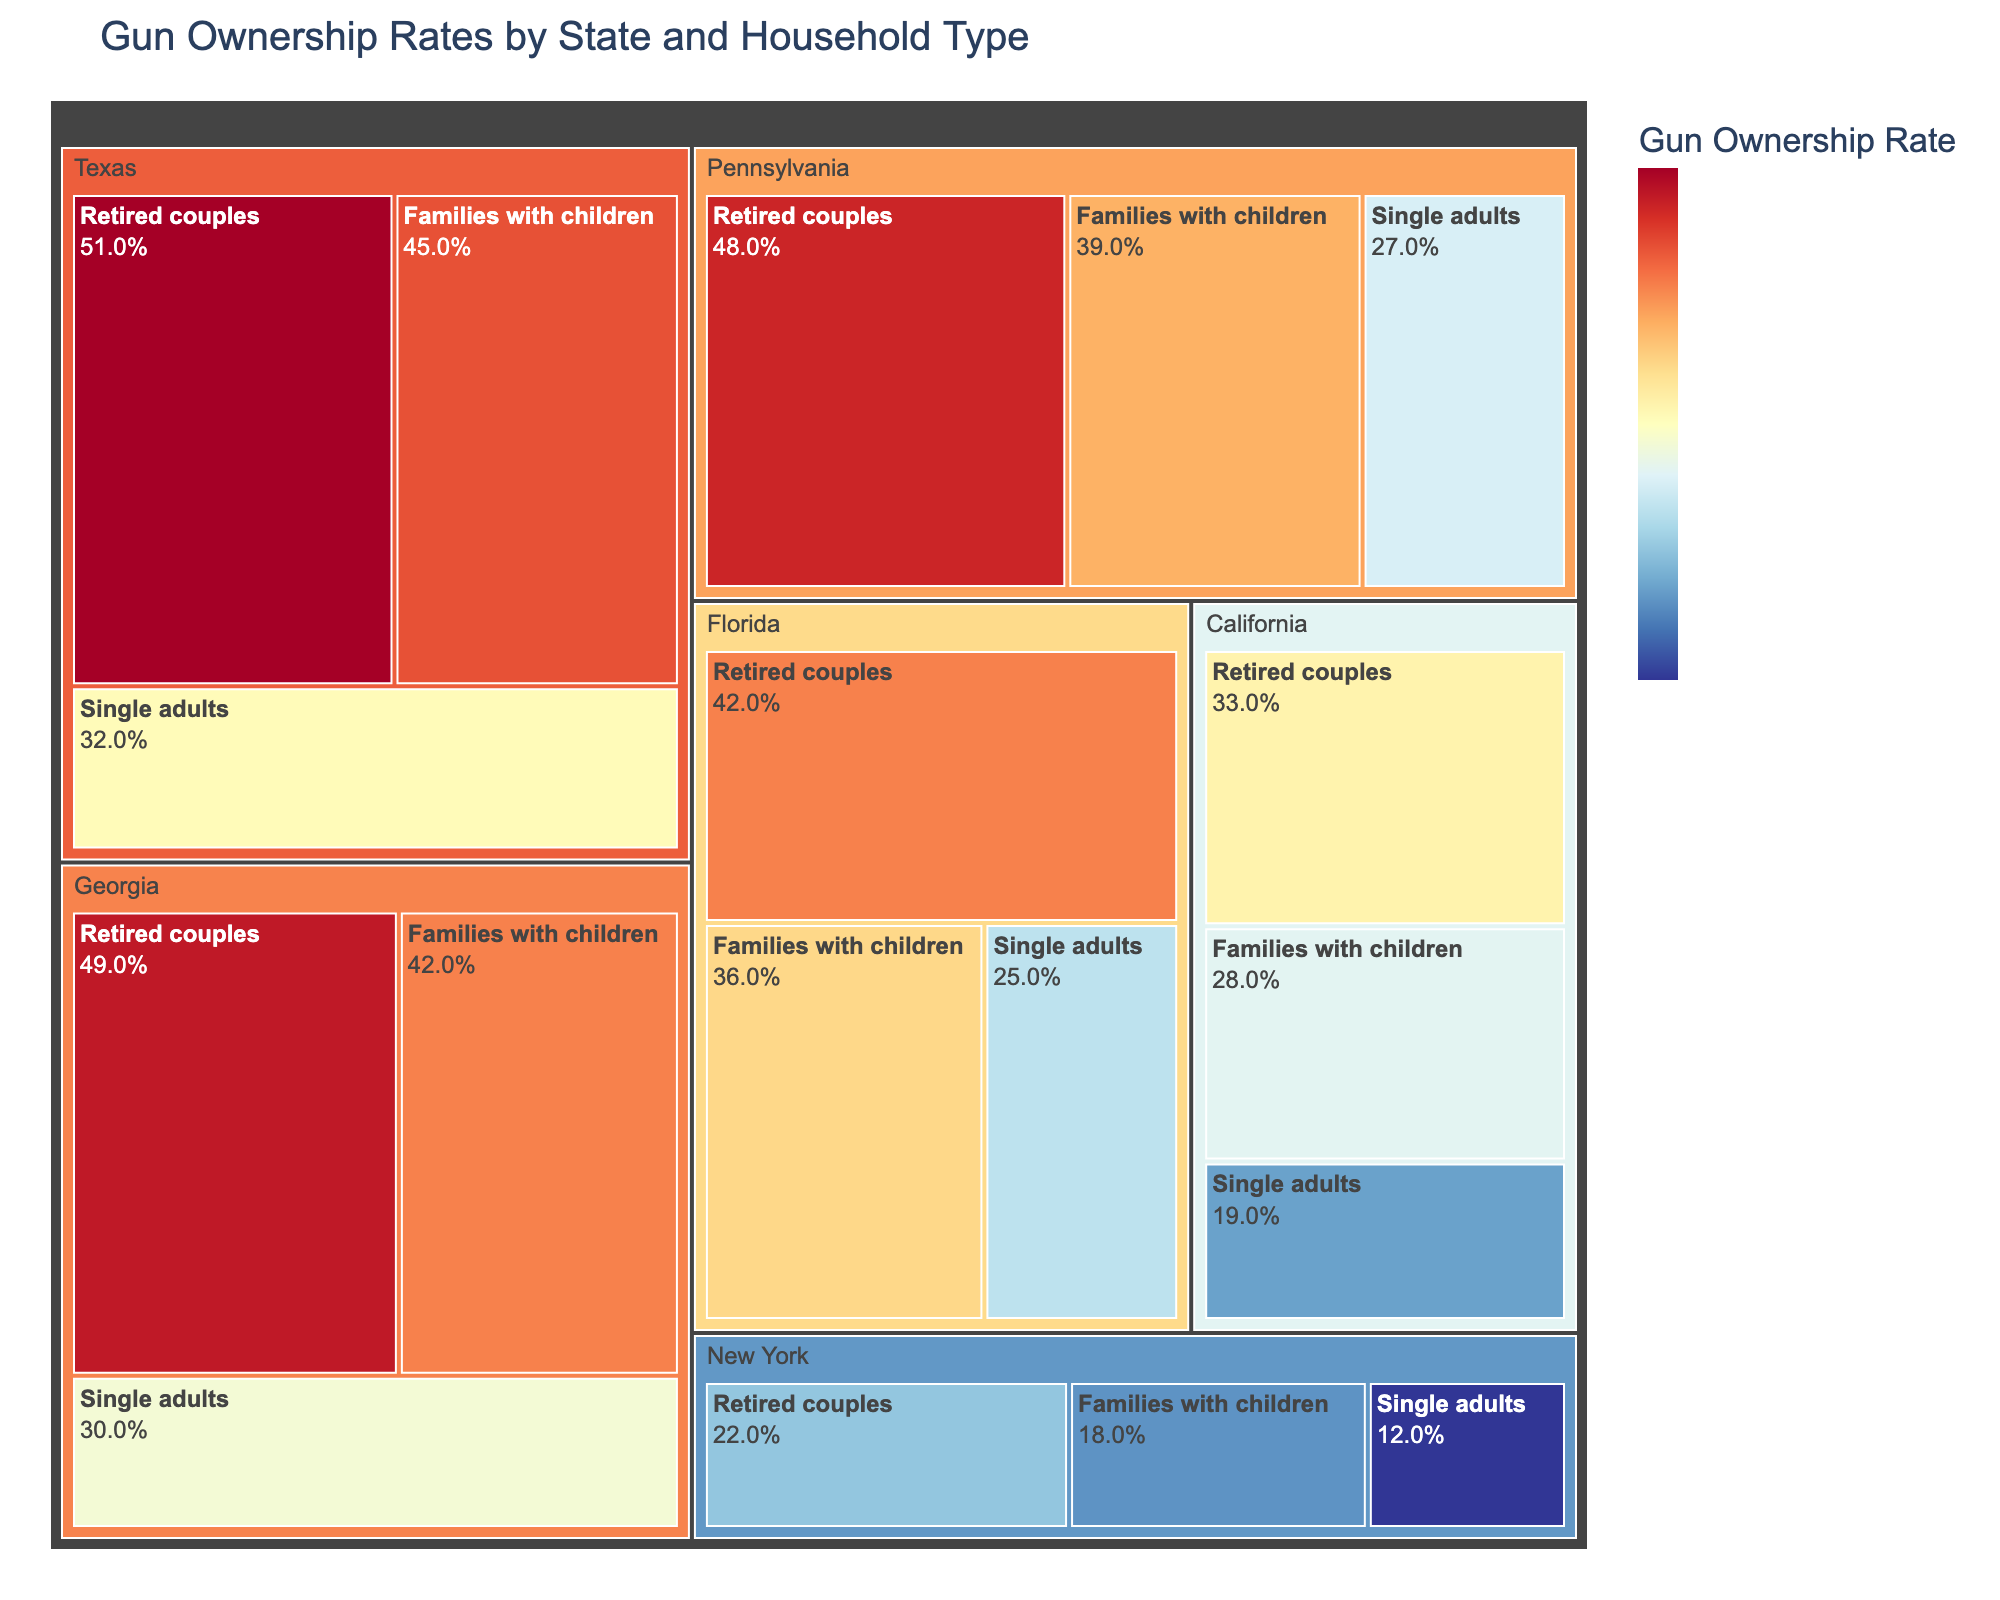What state has the highest gun ownership rate among retired couples? Identify the state with the highest value for "Retired couples" by visually analyzing the respective sections of the Treemap.
Answer: Texas Which household type in New York has the lowest gun ownership rate? Locate New York on the Treemap, then determine which household type ("Families with children," "Single adults," or "Retired couples") has the smallest associated value.
Answer: Single adults What is the average gun ownership rate for all household types in Pennsylvania? Find and sum the gun ownership rates for "Families with children" (0.39), "Single adults" (0.27), and "Retired couples" (0.48). Then, divide by the number of household types (3).
Answer: 0.38 Compare the gun ownership rates of retired couples in California and Florida. Which state has a higher rate? Identify the rates for "Retired couples" in California and Florida, then compare these values.
Answer: Florida What is the difference in gun ownership rate between families with children in Texas and single adults in Georgia? Find the ownership rates for "Families with children" in Texas (0.45) and "Single adults" in Georgia (0.30) and calculate the difference (0.45 - 0.30).
Answer: 0.15 Which state has the lowest overall gun ownership rate for "Single adults"? Compare the "Single adults" ownership rates across all states and identify the smallest value.
Answer: New York Is the gun ownership rate among families with children in Georgia higher or lower than in Pennsylvania? Compare the "Families with children" ownership rates in Georgia (0.42) and Pennsylvania (0.39).
Answer: Higher What is the total gun ownership rate for all household types in Florida? Sum the ownership rates for "Families with children" (0.36), "Single adults" (0.25), and "Retired couples" (0.42).
Answer: 1.03 How does the gun ownership rate among families with children in California compare to that in New York? Compare the "Families with children" ownership rates in California (0.28) and New York (0.18).
Answer: Higher 